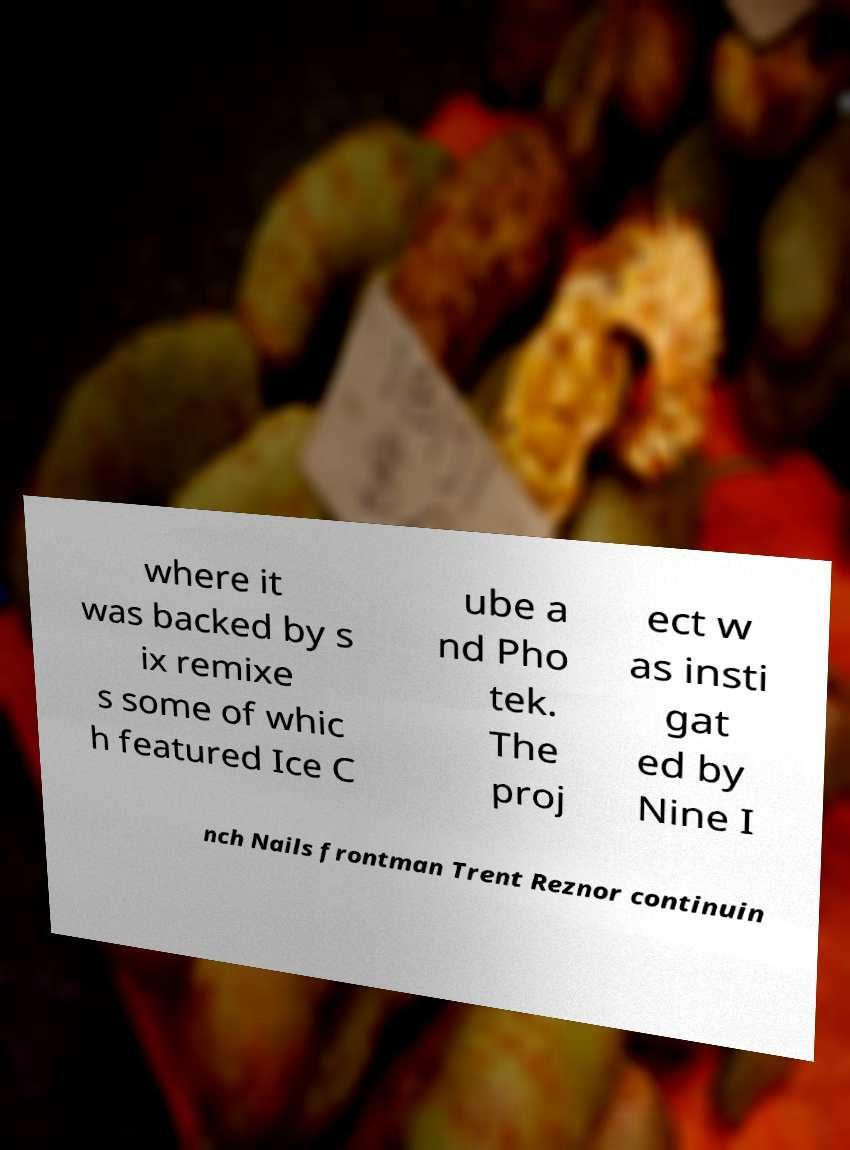I need the written content from this picture converted into text. Can you do that? where it was backed by s ix remixe s some of whic h featured Ice C ube a nd Pho tek. The proj ect w as insti gat ed by Nine I nch Nails frontman Trent Reznor continuin 